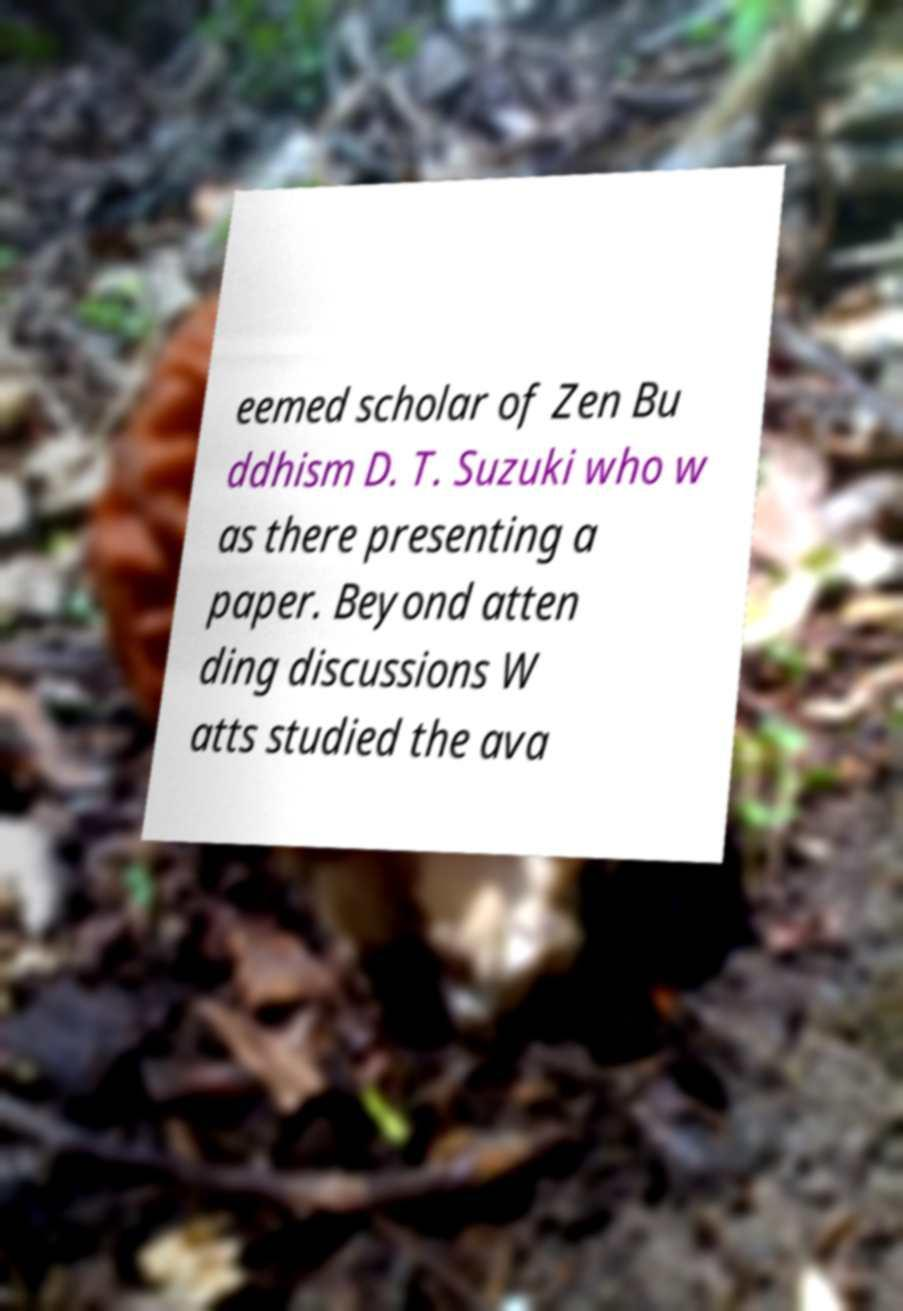Can you read and provide the text displayed in the image?This photo seems to have some interesting text. Can you extract and type it out for me? eemed scholar of Zen Bu ddhism D. T. Suzuki who w as there presenting a paper. Beyond atten ding discussions W atts studied the ava 